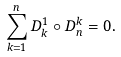Convert formula to latex. <formula><loc_0><loc_0><loc_500><loc_500>\sum _ { k = 1 } ^ { n } D ^ { 1 } _ { k } \circ D ^ { k } _ { n } = 0 .</formula> 